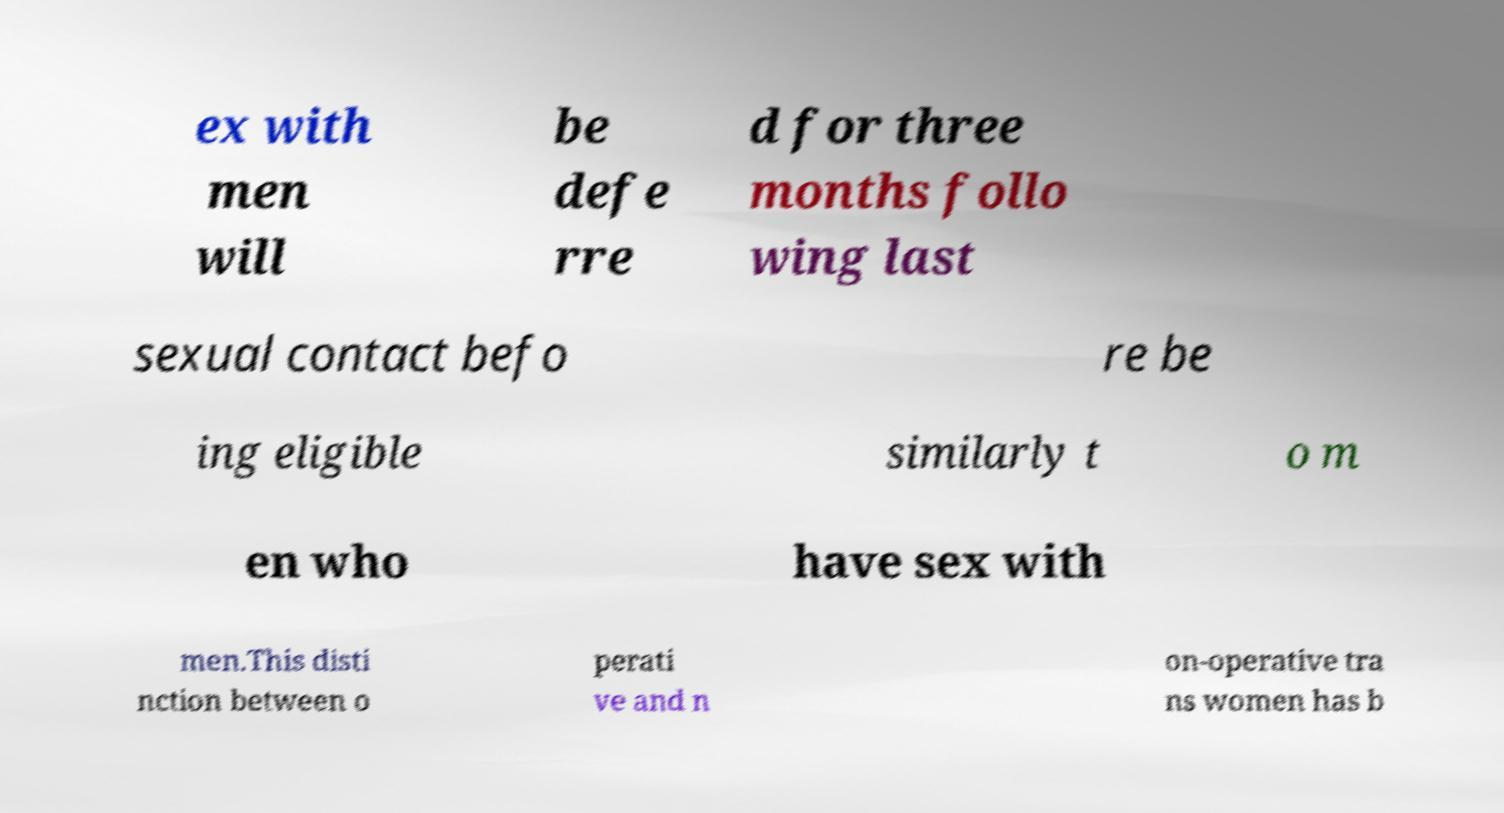Could you extract and type out the text from this image? ex with men will be defe rre d for three months follo wing last sexual contact befo re be ing eligible similarly t o m en who have sex with men.This disti nction between o perati ve and n on-operative tra ns women has b 